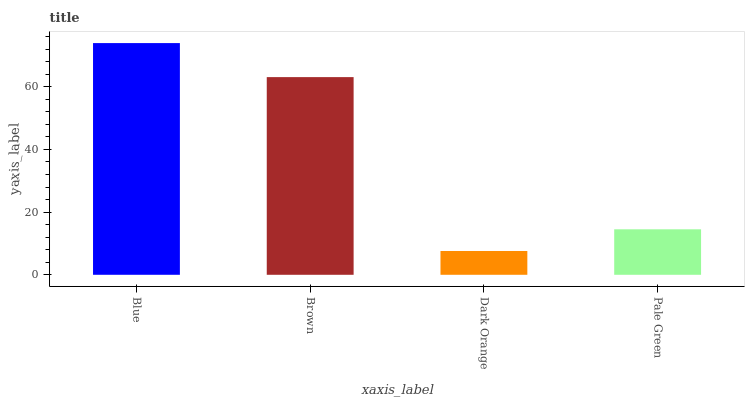Is Brown the minimum?
Answer yes or no. No. Is Brown the maximum?
Answer yes or no. No. Is Blue greater than Brown?
Answer yes or no. Yes. Is Brown less than Blue?
Answer yes or no. Yes. Is Brown greater than Blue?
Answer yes or no. No. Is Blue less than Brown?
Answer yes or no. No. Is Brown the high median?
Answer yes or no. Yes. Is Pale Green the low median?
Answer yes or no. Yes. Is Blue the high median?
Answer yes or no. No. Is Dark Orange the low median?
Answer yes or no. No. 